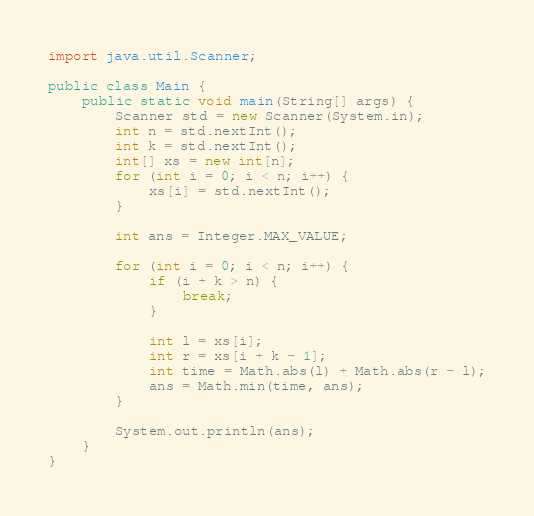Convert code to text. <code><loc_0><loc_0><loc_500><loc_500><_Java_>import java.util.Scanner;

public class Main {
    public static void main(String[] args) {
        Scanner std = new Scanner(System.in);
        int n = std.nextInt();
        int k = std.nextInt();
        int[] xs = new int[n];
        for (int i = 0; i < n; i++) {
            xs[i] = std.nextInt();
        }

        int ans = Integer.MAX_VALUE;

        for (int i = 0; i < n; i++) {
            if (i + k > n) {
                break;
            }

            int l = xs[i];
            int r = xs[i + k - 1];
            int time = Math.abs(l) + Math.abs(r - l);
            ans = Math.min(time, ans);
        }

        System.out.println(ans);
    }
}
</code> 